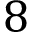<formula> <loc_0><loc_0><loc_500><loc_500>8</formula> 